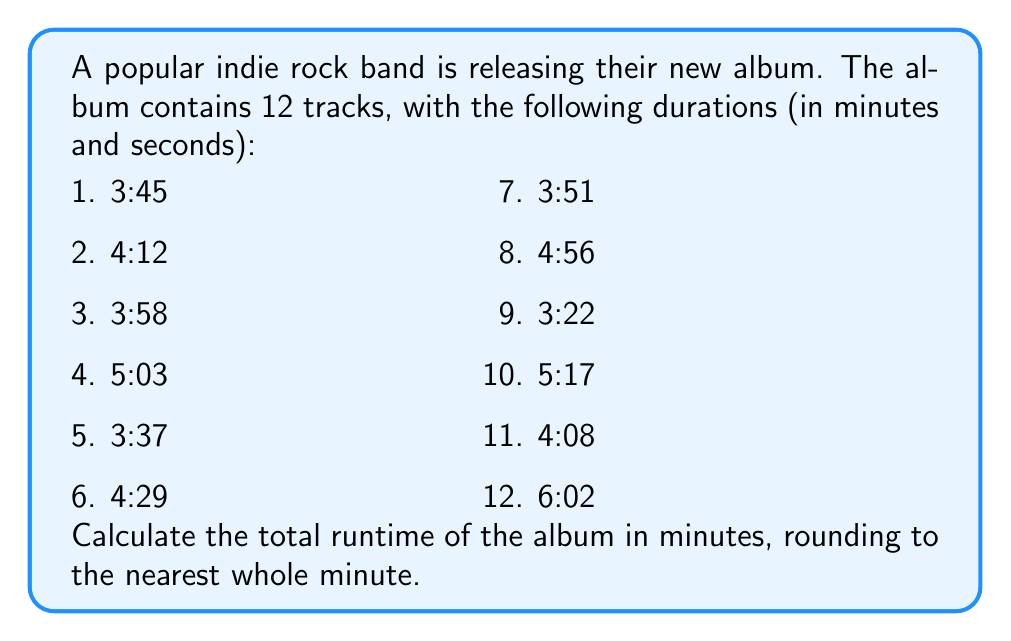Can you solve this math problem? To solve this problem, we need to follow these steps:

1. Convert all track durations to seconds.
2. Sum up the total seconds.
3. Convert the total seconds back to minutes.
4. Round to the nearest whole minute.

Let's go through each step:

1. Converting to seconds:
   For each track, we multiply the minutes by 60 and add the seconds.
   
   Track 1: $3 \times 60 + 45 = 225$ seconds
   Track 2: $4 \times 60 + 12 = 252$ seconds
   Track 3: $3 \times 60 + 58 = 238$ seconds
   Track 4: $5 \times 60 + 3 = 303$ seconds
   Track 5: $3 \times 60 + 37 = 217$ seconds
   Track 6: $4 \times 60 + 29 = 269$ seconds
   Track 7: $3 \times 60 + 51 = 231$ seconds
   Track 8: $4 \times 60 + 56 = 296$ seconds
   Track 9: $3 \times 60 + 22 = 202$ seconds
   Track 10: $5 \times 60 + 17 = 317$ seconds
   Track 11: $4 \times 60 + 8 = 248$ seconds
   Track 12: $6 \times 60 + 2 = 362$ seconds

2. Summing up the total seconds:
   $225 + 252 + 238 + 303 + 217 + 269 + 231 + 296 + 202 + 317 + 248 + 362 = 3160$ seconds

3. Converting total seconds back to minutes:
   $3160 \div 60 = 52.6666...$ minutes

4. Rounding to the nearest whole minute:
   $52.6666...$ rounds to 53 minutes

Therefore, the total runtime of the album is 53 minutes.
Answer: 53 minutes 